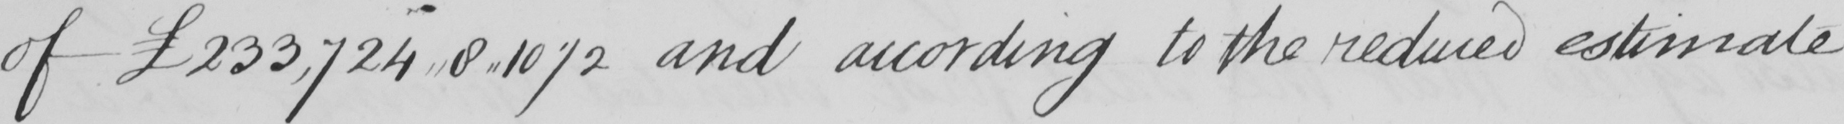Can you tell me what this handwritten text says? of  £233,724,,8,,10 1/2 and according to the reduced estimate 